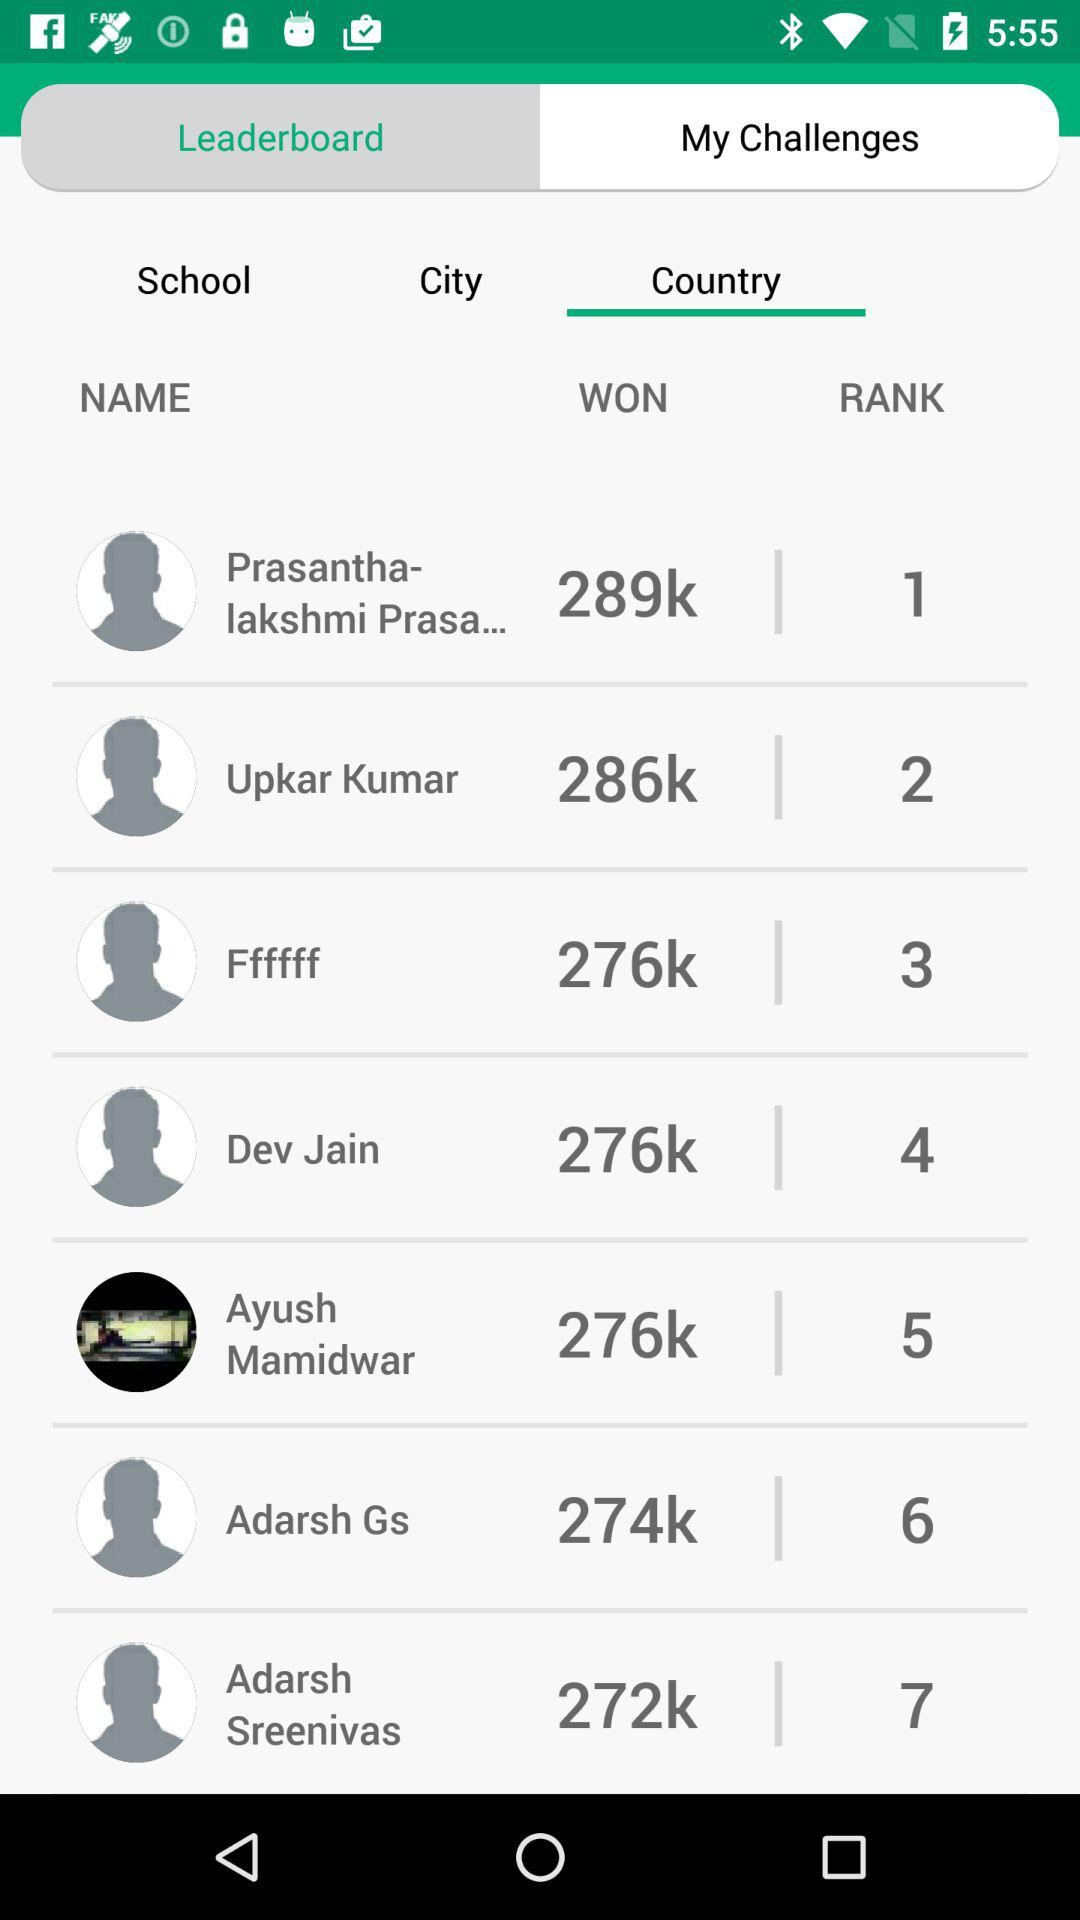What is the winning amount for Adarsh Gs? The winning amount is 274k. 